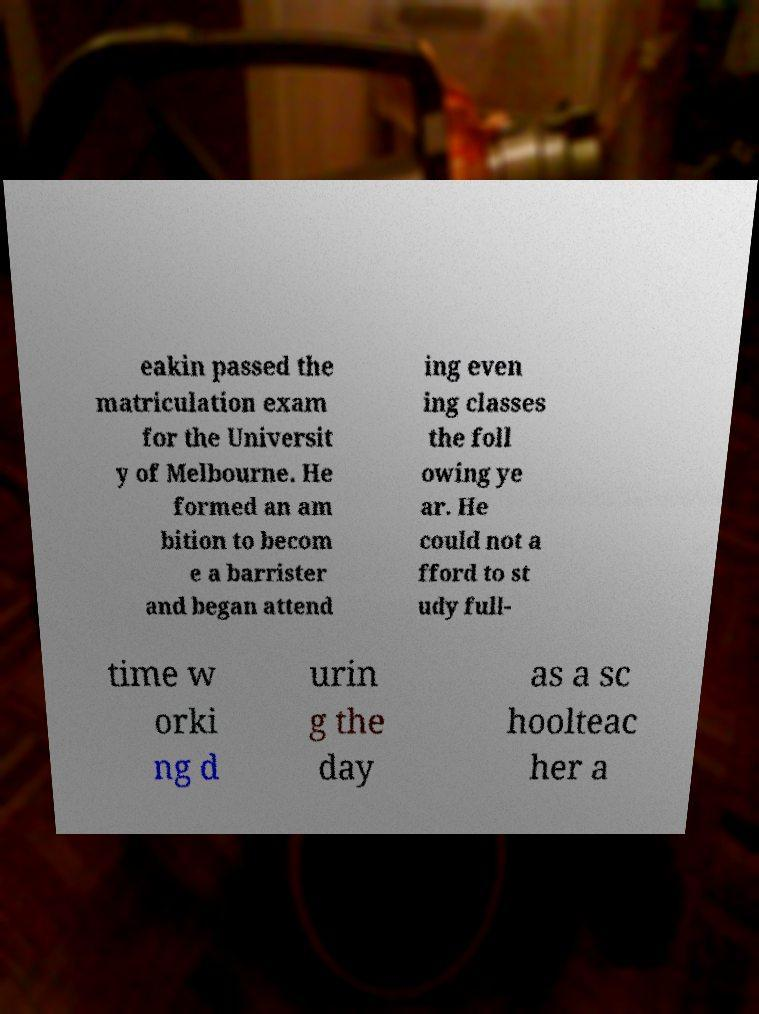Could you assist in decoding the text presented in this image and type it out clearly? eakin passed the matriculation exam for the Universit y of Melbourne. He formed an am bition to becom e a barrister and began attend ing even ing classes the foll owing ye ar. He could not a fford to st udy full- time w orki ng d urin g the day as a sc hoolteac her a 